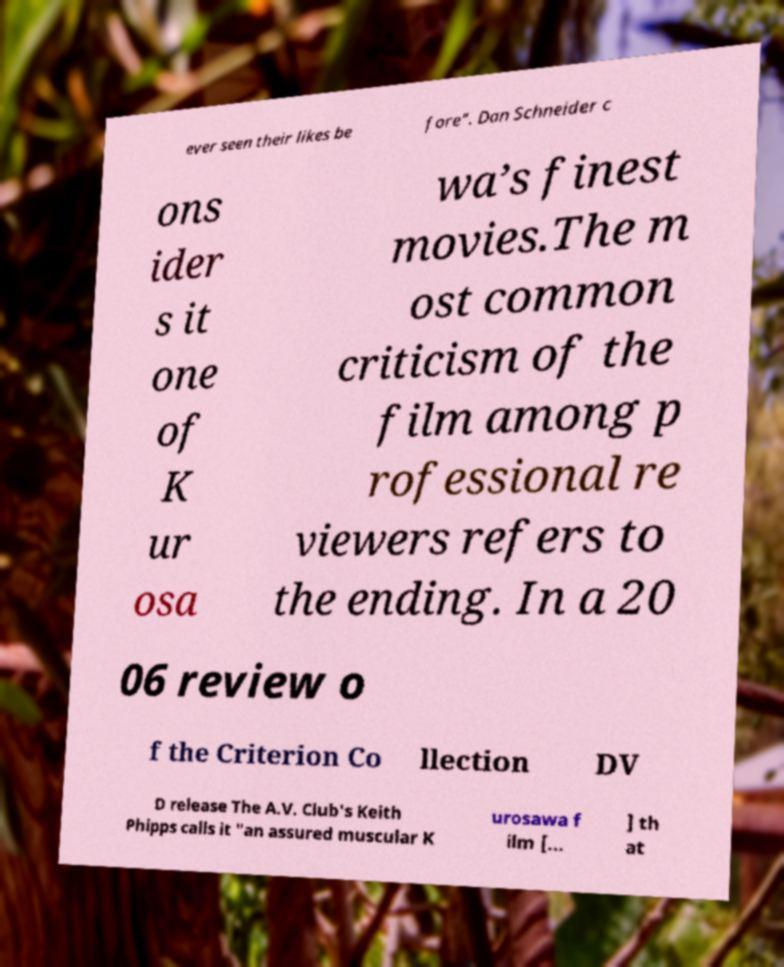For documentation purposes, I need the text within this image transcribed. Could you provide that? ever seen their likes be fore”. Dan Schneider c ons ider s it one of K ur osa wa’s finest movies.The m ost common criticism of the film among p rofessional re viewers refers to the ending. In a 20 06 review o f the Criterion Co llection DV D release The A.V. Club's Keith Phipps calls it "an assured muscular K urosawa f ilm [... ] th at 